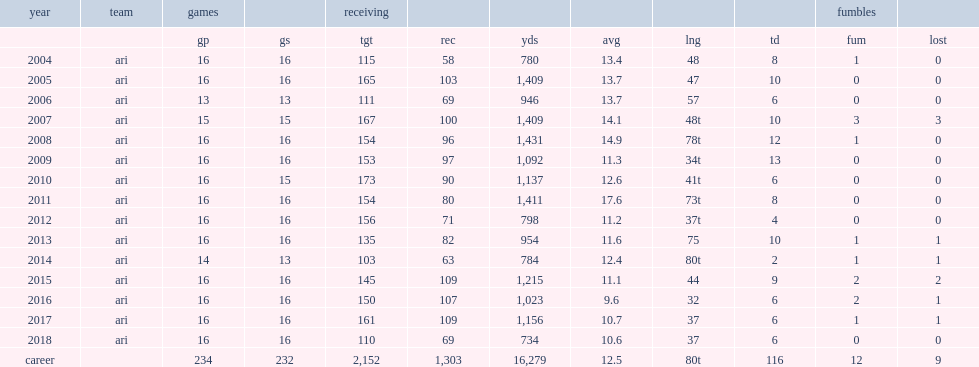How many receiving yards did fitzgerald get in 2015? 1215.0. 